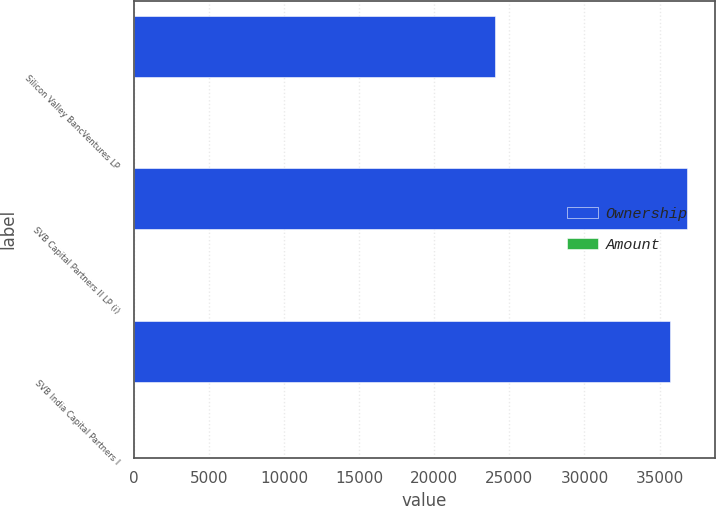<chart> <loc_0><loc_0><loc_500><loc_500><stacked_bar_chart><ecel><fcel>Silicon Valley BancVentures LP<fcel>SVB Capital Partners II LP (i)<fcel>SVB India Capital Partners I<nl><fcel>Ownership<fcel>24023<fcel>36847<fcel>35707<nl><fcel>Amount<fcel>10.7<fcel>5.1<fcel>14.4<nl></chart> 